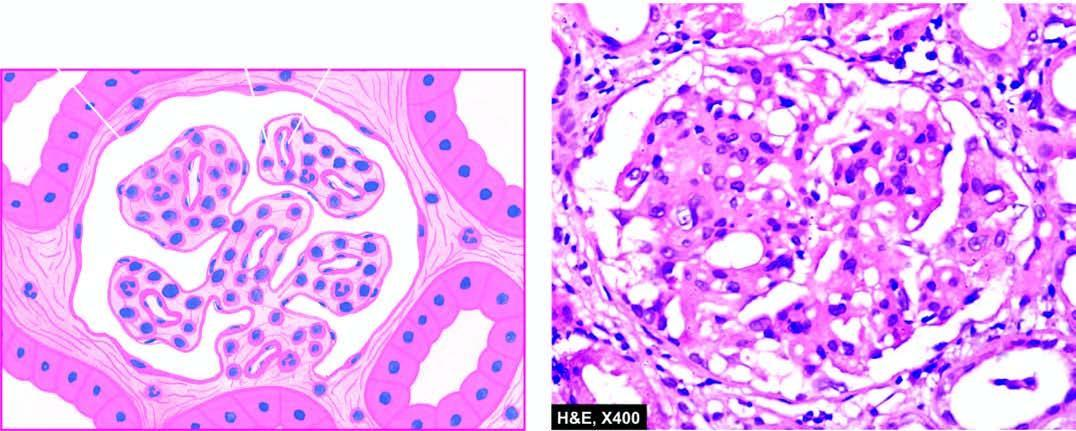what do the glomerular tufts show?
Answer the question using a single word or phrase. Lobulation and mesangial hypercellularity 